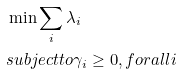Convert formula to latex. <formula><loc_0><loc_0><loc_500><loc_500>& \min \sum _ { i } \lambda _ { i } \\ & s u b j e c t t o \gamma _ { i } \geq 0 , f o r a l l i</formula> 